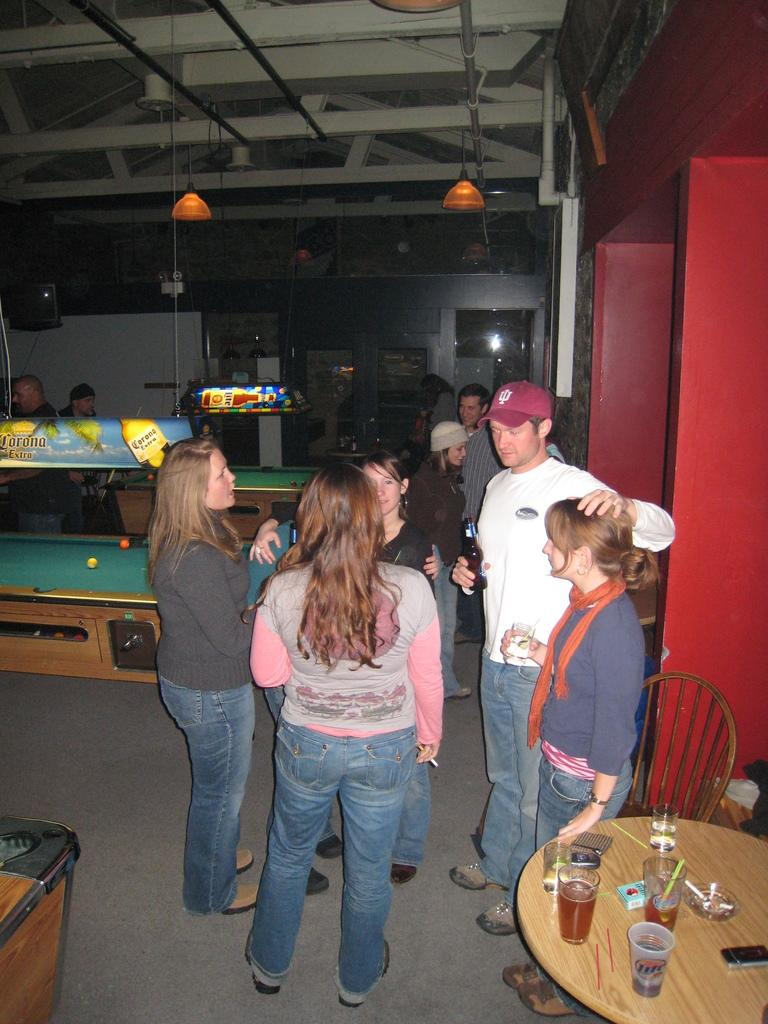What is happening in the image? There are people standing in the image. What objects are on the right side of the image? There is a chair and a table on the right side of the image. What items can be seen on the table? There are glasses and mobile phones on the table. Can you see a goldfish swimming in the image? There is no goldfish present in the image. What type of branch is being used by the people in the image? There is no branch visible in the image. 